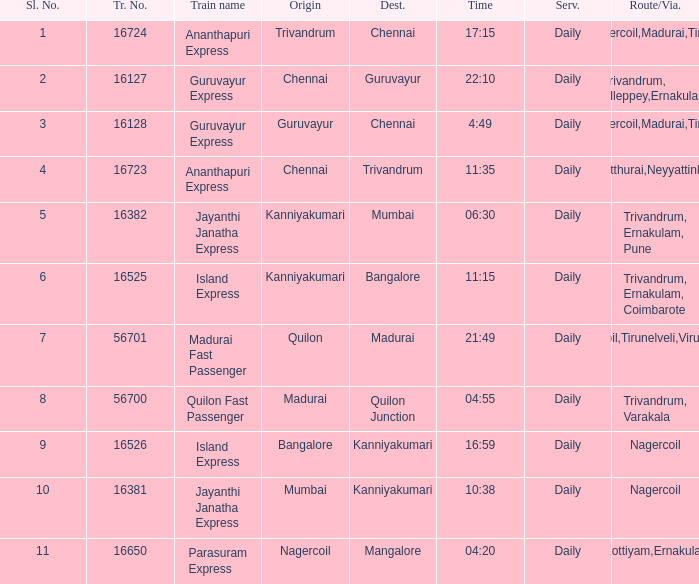What is the train number when the time is 10:38? 16381.0. 